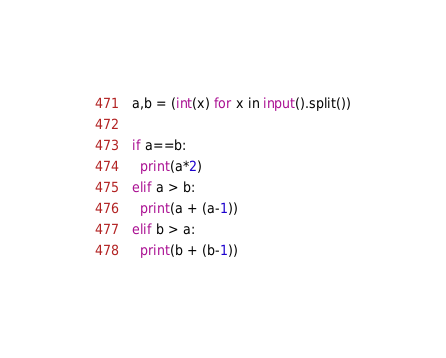Convert code to text. <code><loc_0><loc_0><loc_500><loc_500><_Python_>a,b = (int(x) for x in input().split())

if a==b:
  print(a*2)
elif a > b:
  print(a + (a-1))
elif b > a:
  print(b + (b-1))</code> 